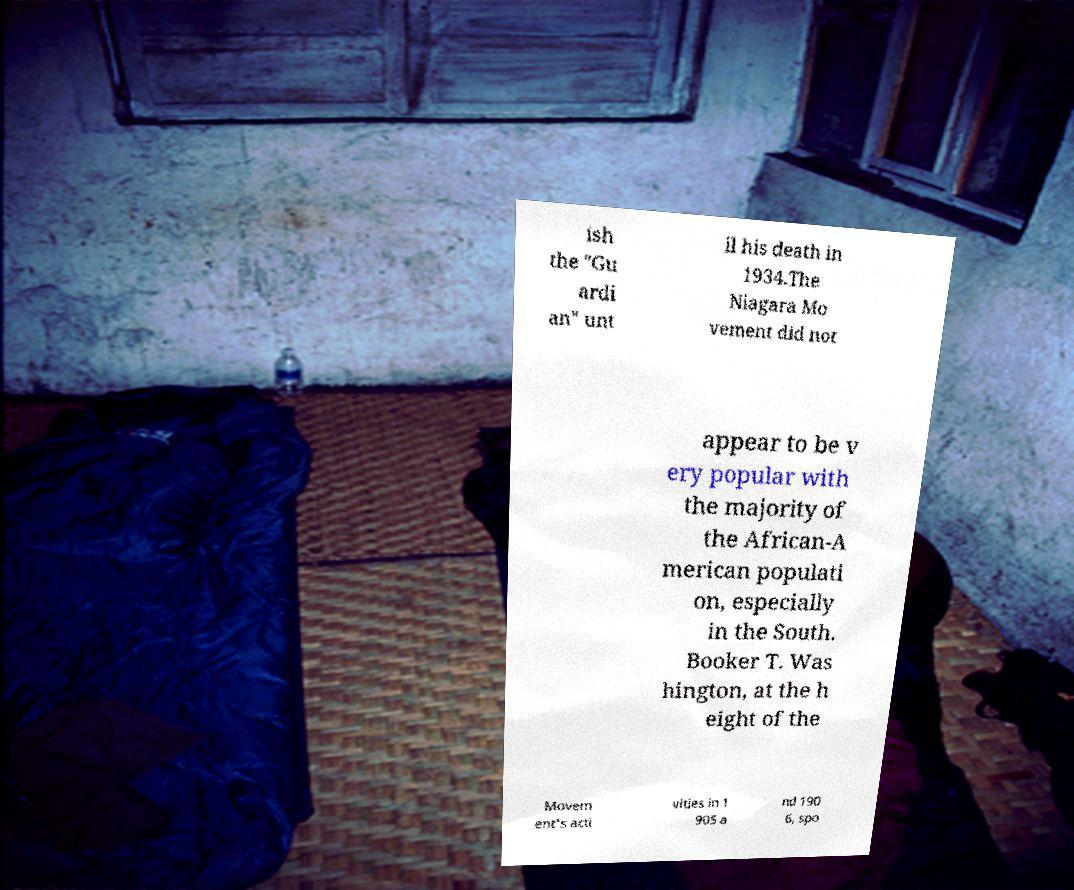For documentation purposes, I need the text within this image transcribed. Could you provide that? ish the "Gu ardi an" unt il his death in 1934.The Niagara Mo vement did not appear to be v ery popular with the majority of the African-A merican populati on, especially in the South. Booker T. Was hington, at the h eight of the Movem ent's acti vities in 1 905 a nd 190 6, spo 